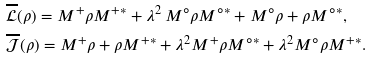<formula> <loc_0><loc_0><loc_500><loc_500>& \mathcal { \overline { L } } ( \rho ) = M ^ { + } \rho M ^ { + * } + \lambda ^ { 2 } \, M ^ { \circ } \rho M ^ { \circ * } + M ^ { \circ } \rho + \rho M ^ { \circ * } , \\ & \mathcal { \overline { J } } ( \rho ) = M ^ { + } \rho + \rho M ^ { + * } + \lambda ^ { 2 } M ^ { + } \rho M ^ { \circ * } + \lambda ^ { 2 } M ^ { \circ } \rho M ^ { + * } .</formula> 